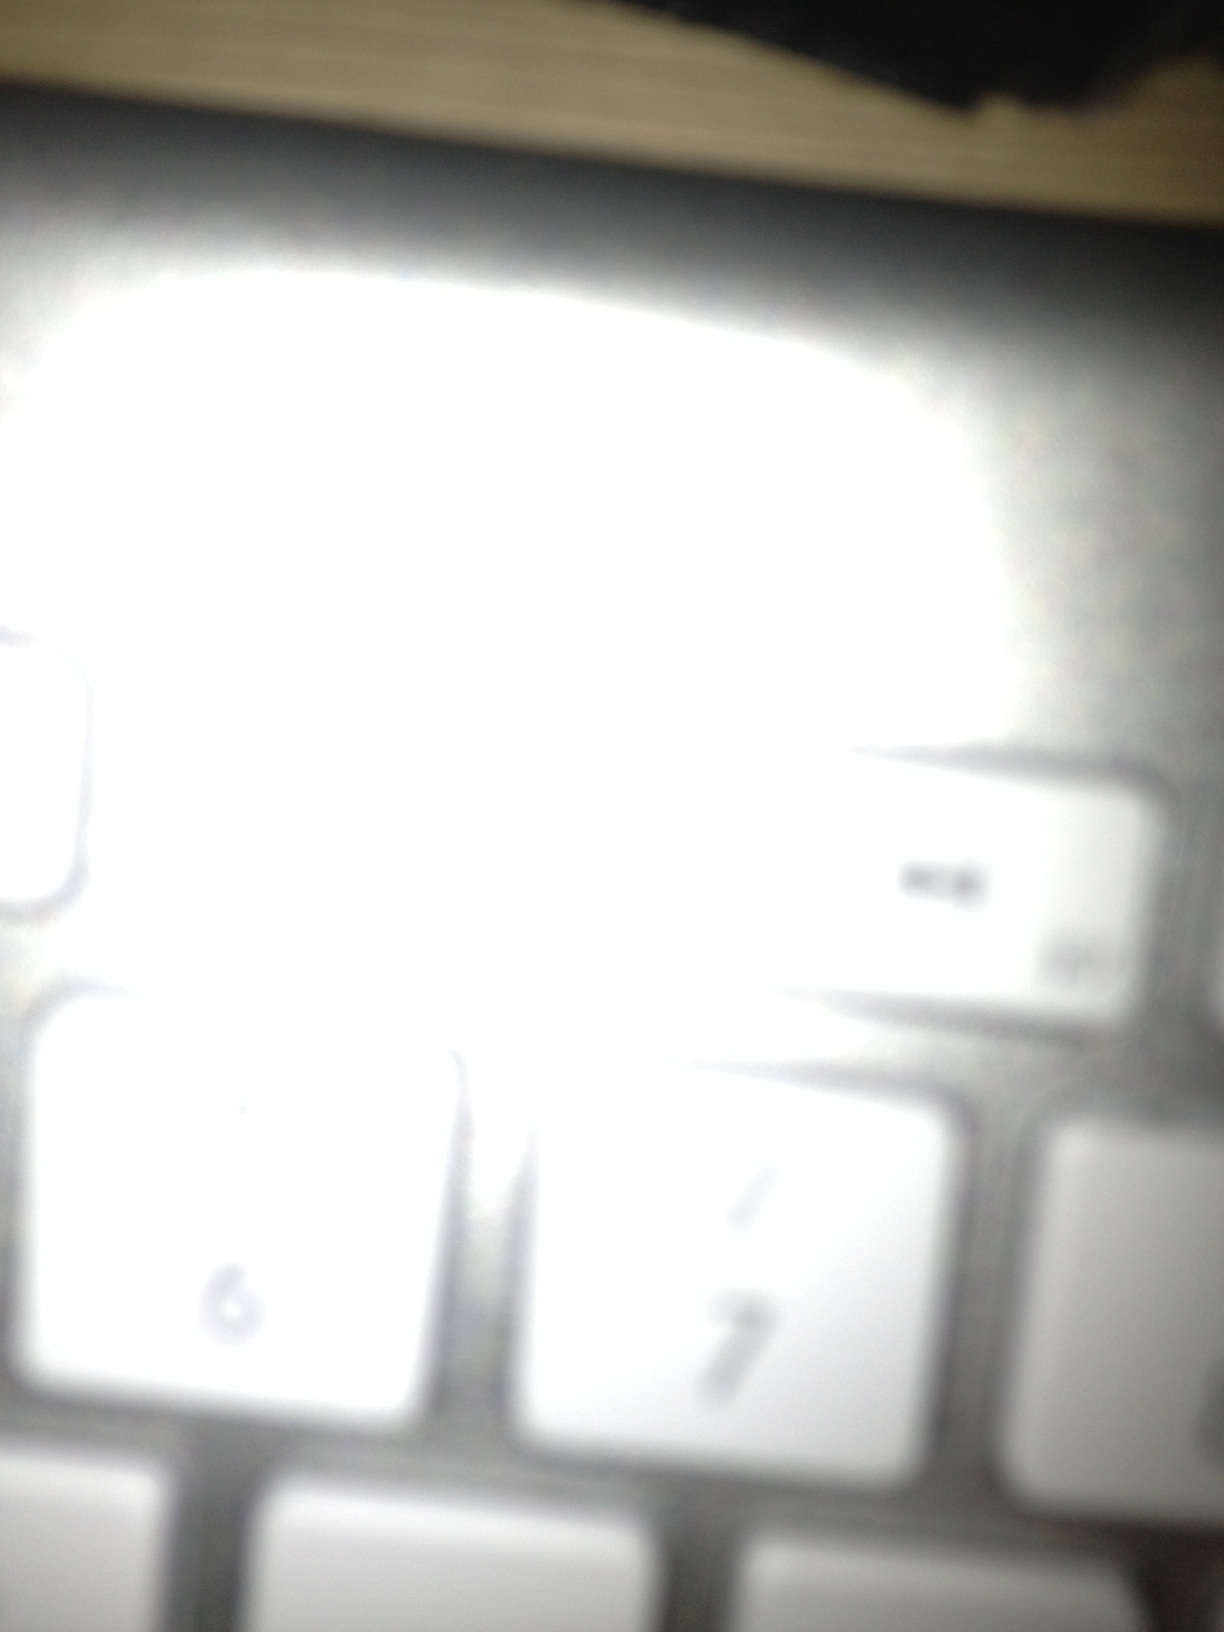What kind of keyboard do you think this is? The image shows part of a keyboard that appears to be from a common layout, likely from a desktop or laptop computer. Given the standard number keys, this could be a keyboard produced by a major electronics manufacturer. The specific brand or model cannot be determined due to the blurriness and overexposure. If this keyboard could talk, what story might it tell? If this keyboard could talk, it might share stories of countless hours aiding users in work, study, and play. Perhaps it would recount the late-night deadlines met, the moments of frustration when keys were pounded in haste, and the quiet times when it was left untouched. Each key press contributing to its digital history. Imagine this keyboard is part of a sci-fi novel; describe a scenario involving it. In a distant future, on the spaceship 'Aurora,' this keyboard was more than a simple input device; it was the command center interface for the ship's AI system, ECHO. Although it seemed ordinary, it held the secrets to countless navigation logs, encrypted messages from interstellar allies, and even the power to override the mainframe. One day, during a critical mission, when the fate of civilizations depended on a single keystroke, the slightly worn number 7 key became the ultimate savior of humanity. When pressed, it activated a hidden protocol that rerouted the ship away from an imminent collision with an uncharted planet, saving not only the crew but countless lives back on Earth. 